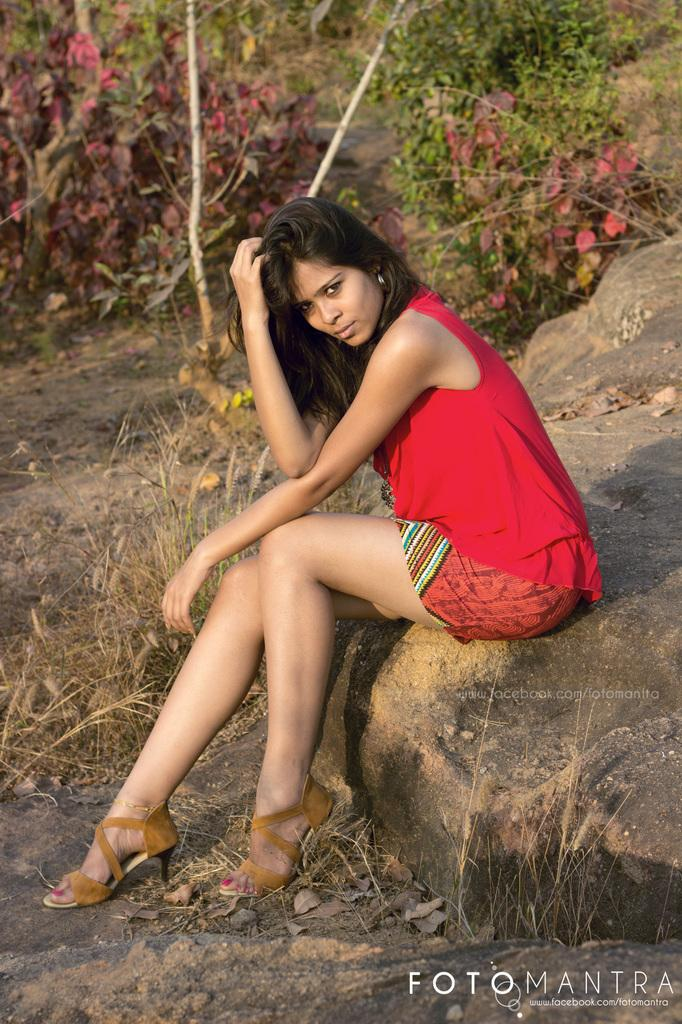Who is the main subject in the image? There is a woman in the image. What is the woman doing in the image? The woman is sitting on a rock. What type of natural elements can be seen in the image? Dried leaves are present in the image, and there are trees in the background. What type of stew is the woman preparing in the image? There is no indication in the image that the woman is preparing any type of stew. How does the woman rub her hands together in the image? There is no action of the woman rubbing her hands together in the image. 